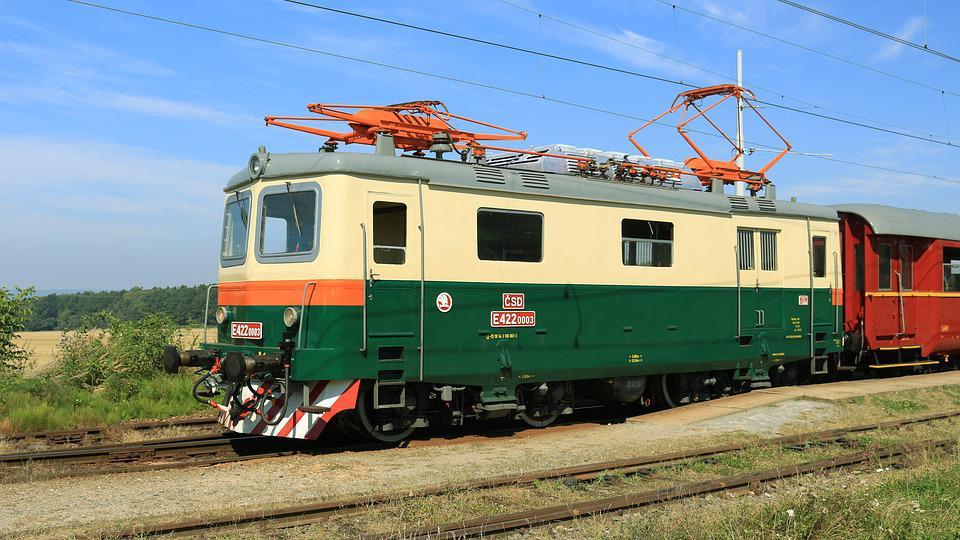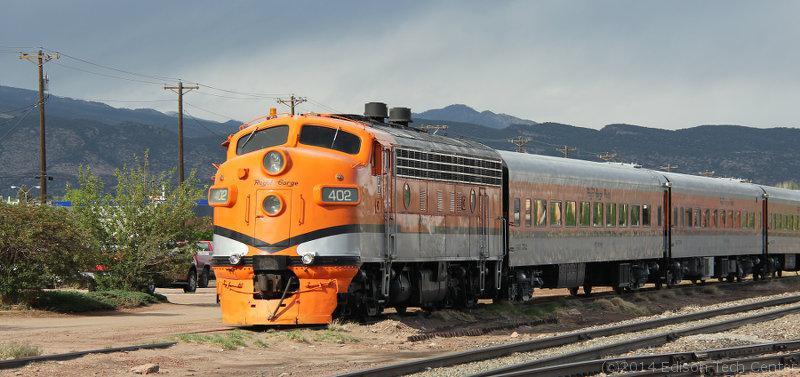The first image is the image on the left, the second image is the image on the right. For the images shown, is this caption "Both images show a train with at least one train car, and both trains are headed in the same direction and will not collide." true? Answer yes or no. Yes. 